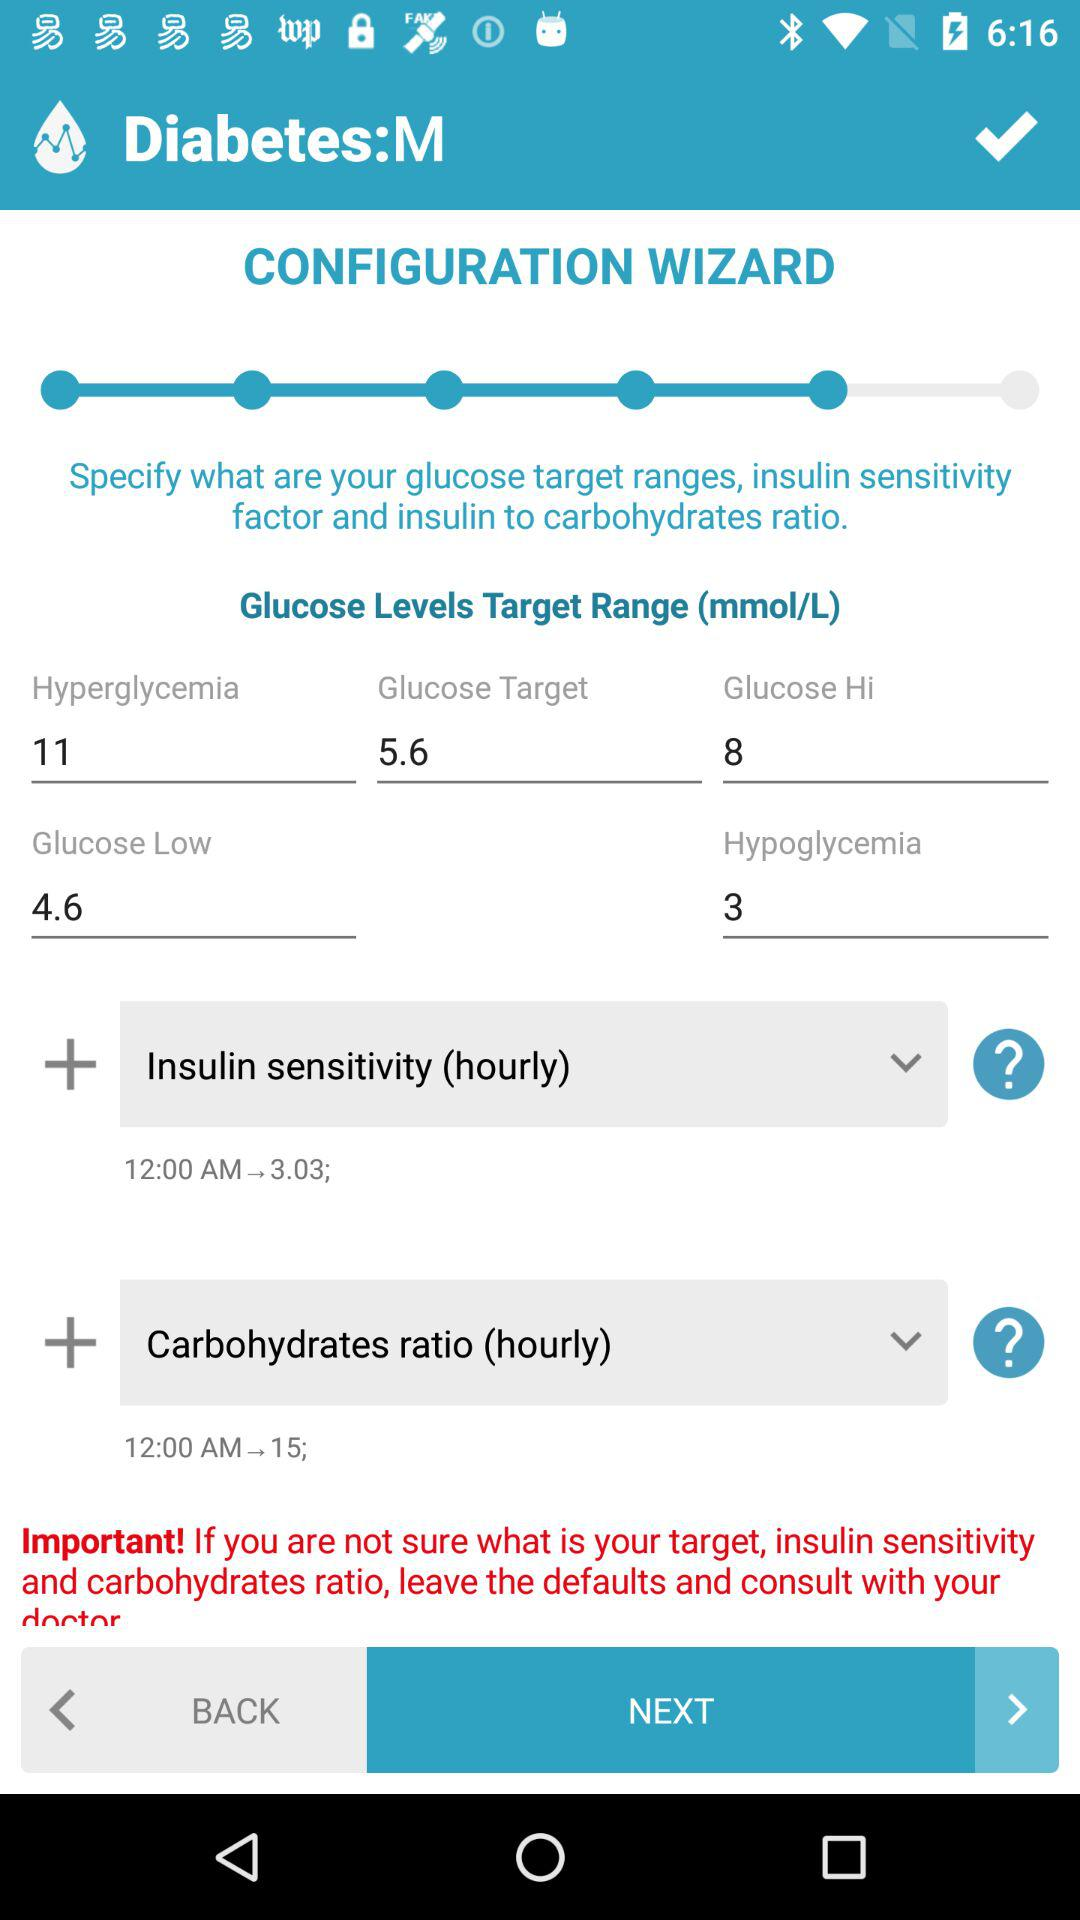Who is this application powered by?
When the provided information is insufficient, respond with <no answer>. <no answer> 